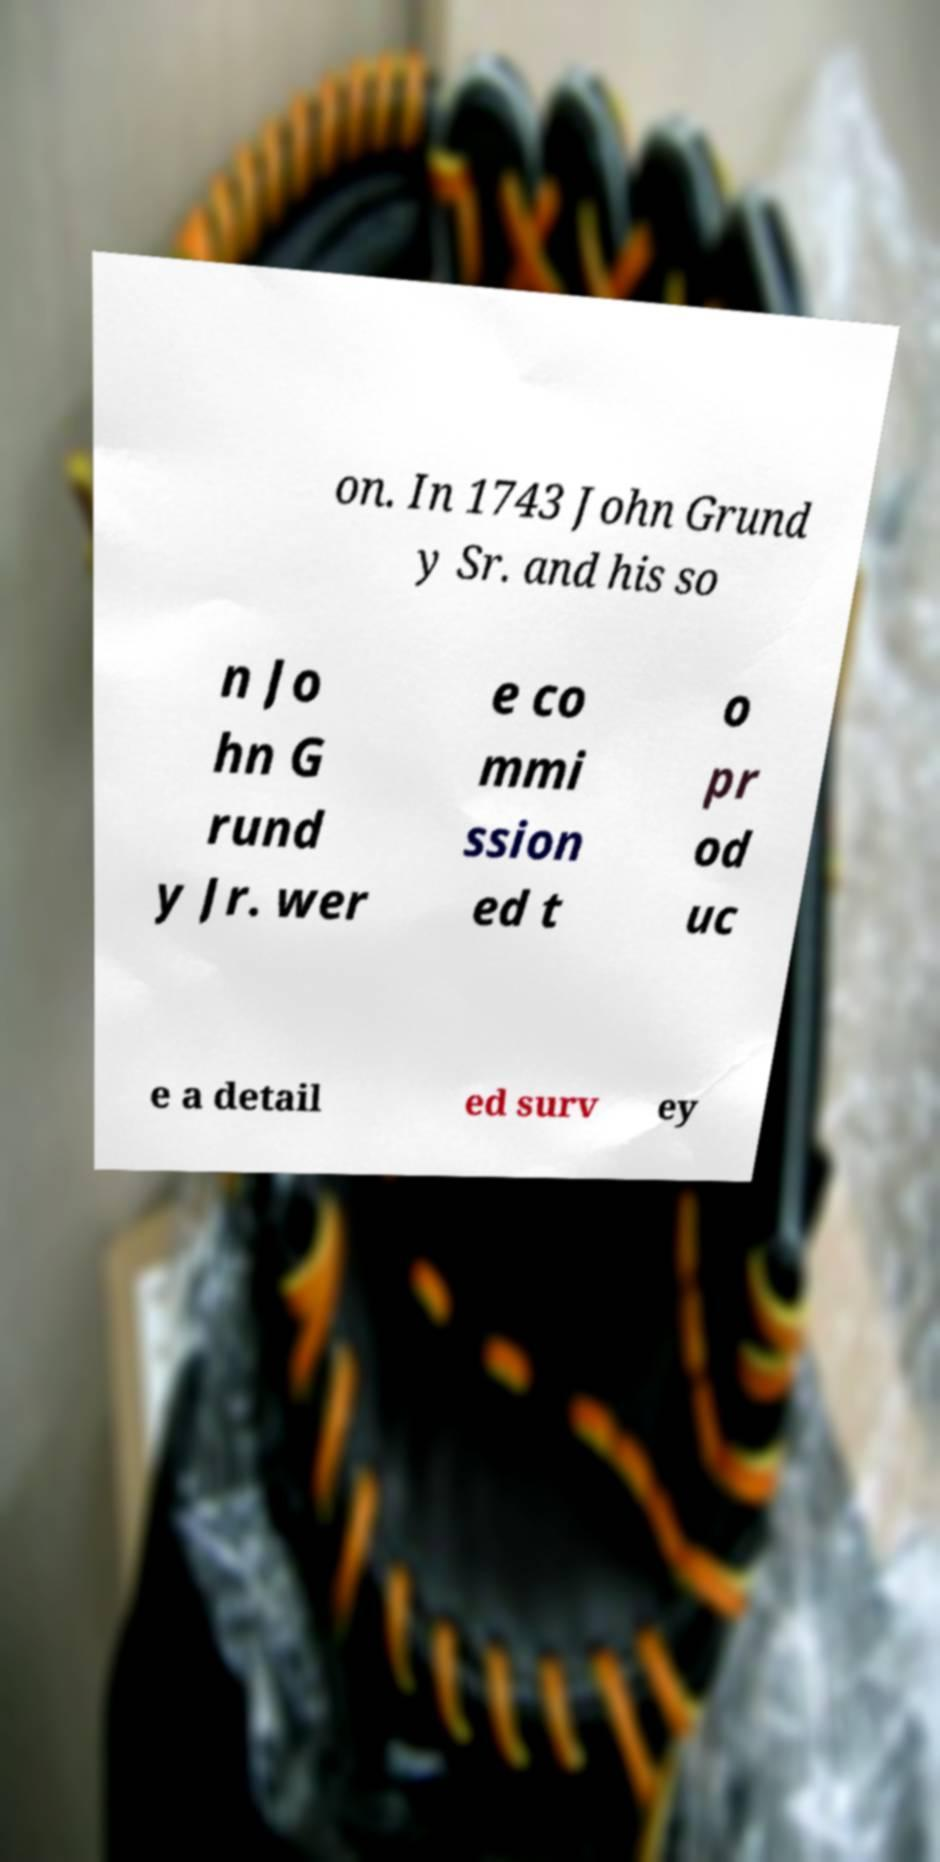Can you accurately transcribe the text from the provided image for me? on. In 1743 John Grund y Sr. and his so n Jo hn G rund y Jr. wer e co mmi ssion ed t o pr od uc e a detail ed surv ey 